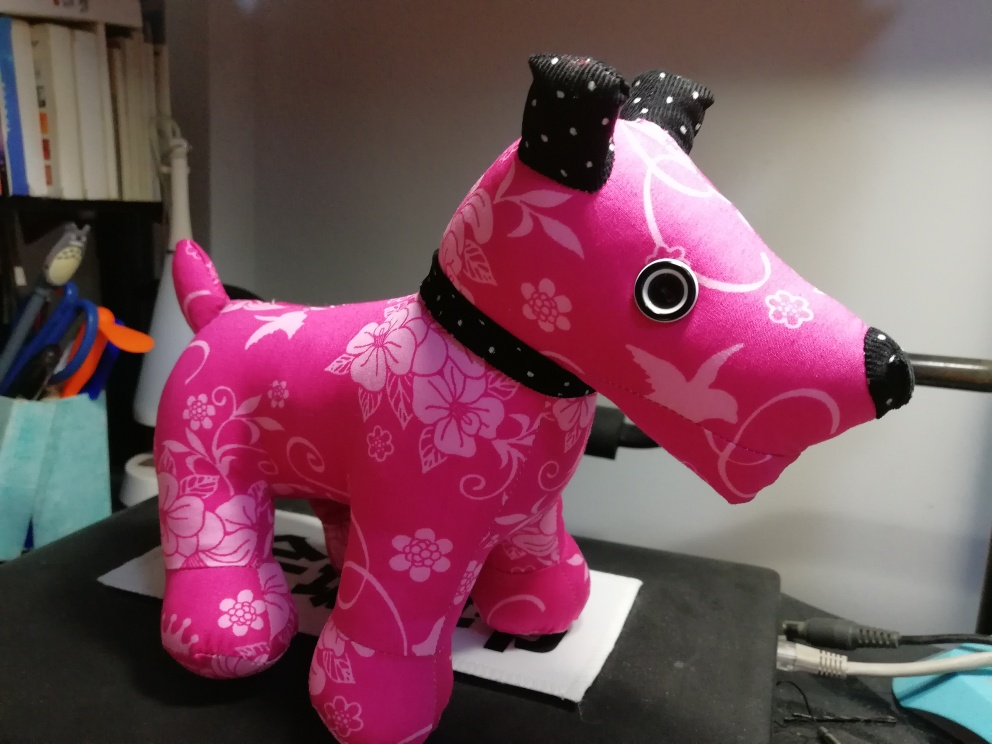Is the lighting sufficient in the image? The lighting in the image appears to be ample for clear visibility, highlighting the vibrant pink color and the floral patterns on the surface of the dog-shaped object. 